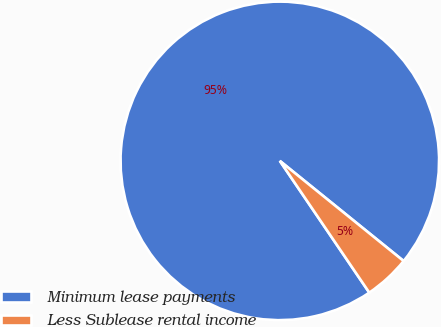<chart> <loc_0><loc_0><loc_500><loc_500><pie_chart><fcel>Minimum lease payments<fcel>Less Sublease rental income<nl><fcel>95.32%<fcel>4.68%<nl></chart> 